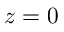Convert formula to latex. <formula><loc_0><loc_0><loc_500><loc_500>z = 0</formula> 